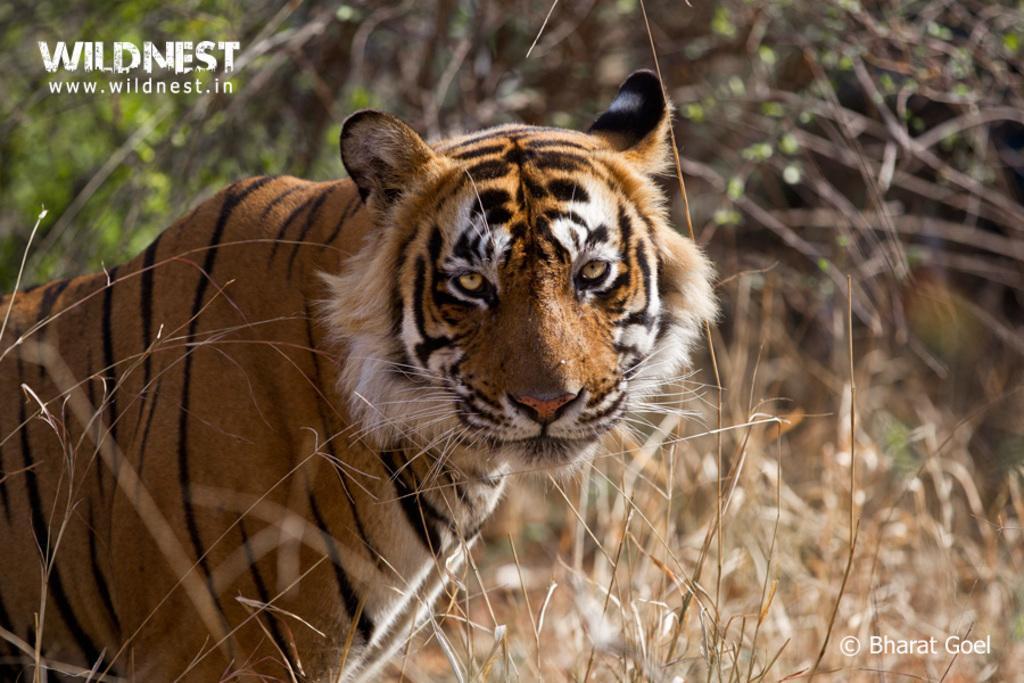Please provide a concise description of this image. In In this we can see a tiger on the path and behind the tiger there are trees. On the image there are watermarks. 